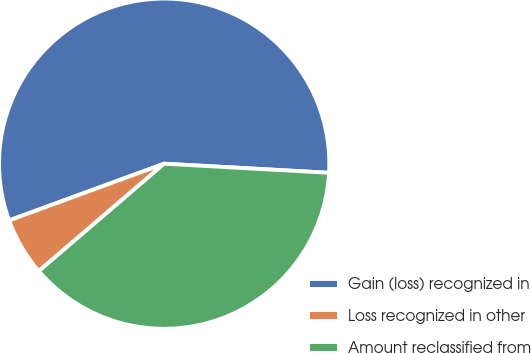<chart> <loc_0><loc_0><loc_500><loc_500><pie_chart><fcel>Gain (loss) recognized in<fcel>Loss recognized in other<fcel>Amount reclassified from<nl><fcel>56.46%<fcel>5.69%<fcel>37.85%<nl></chart> 